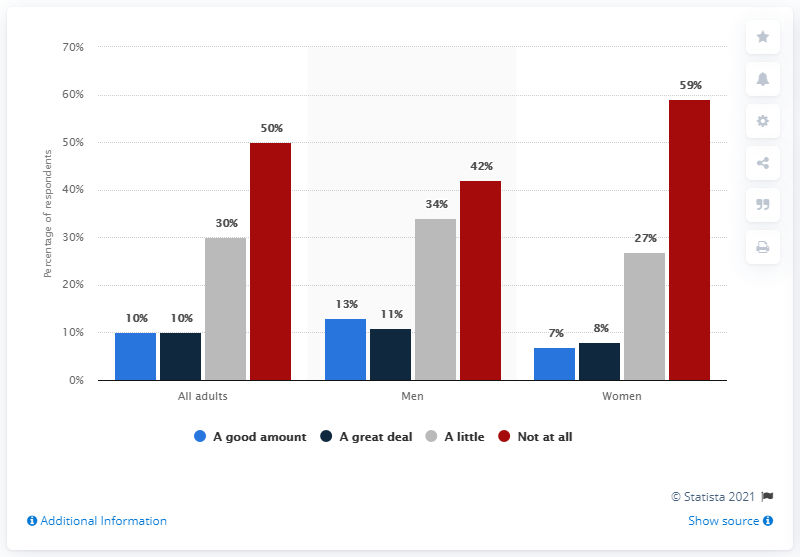Point out several critical features in this image. The ratio between men and women in the "Not at all" category is 0.711864407... According to the given data, in the "women" category, 59% of the respondents said that they did not experience any symptoms of PCOS. A significant 13% of male respondents are deeply engaged in baseball, 